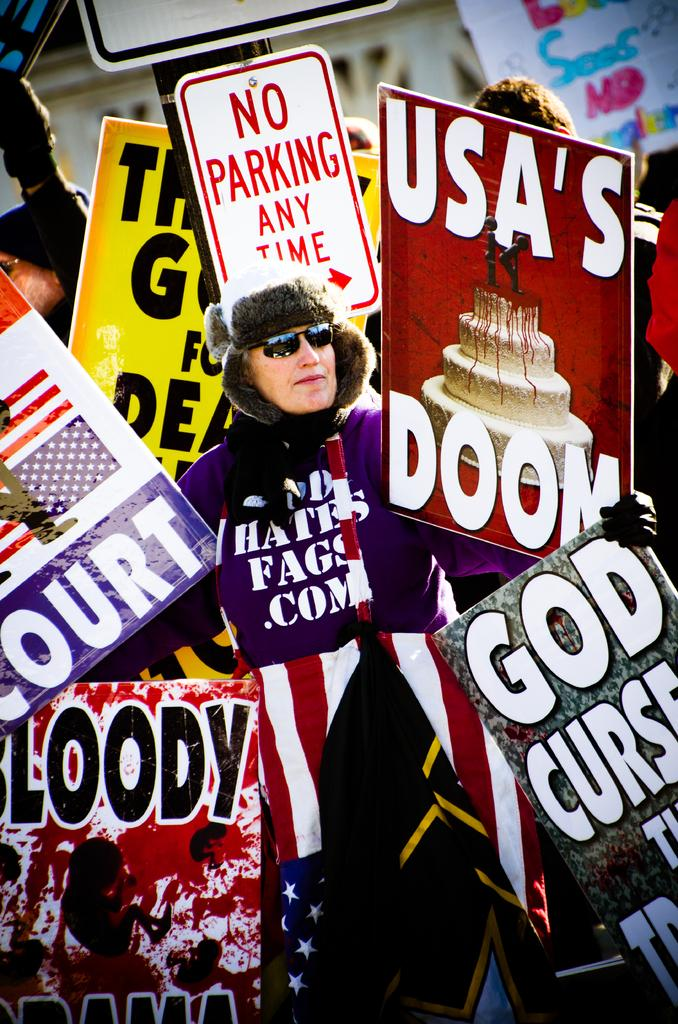Who or what can be seen in the image? There are people in the image. What are the people doing in the image? The people are standing in the image. What are the people holding in their hands? The people are holding placards in their hands. What type of sack can be seen on the people's heads in the image? There are no sacks present on the people's heads in the image. What thing is being protested or promoted by the people holding placards in the image? The image does not provide information about the specific message or cause on the placards, so we cannot determine what thing is being protested or promoted. 